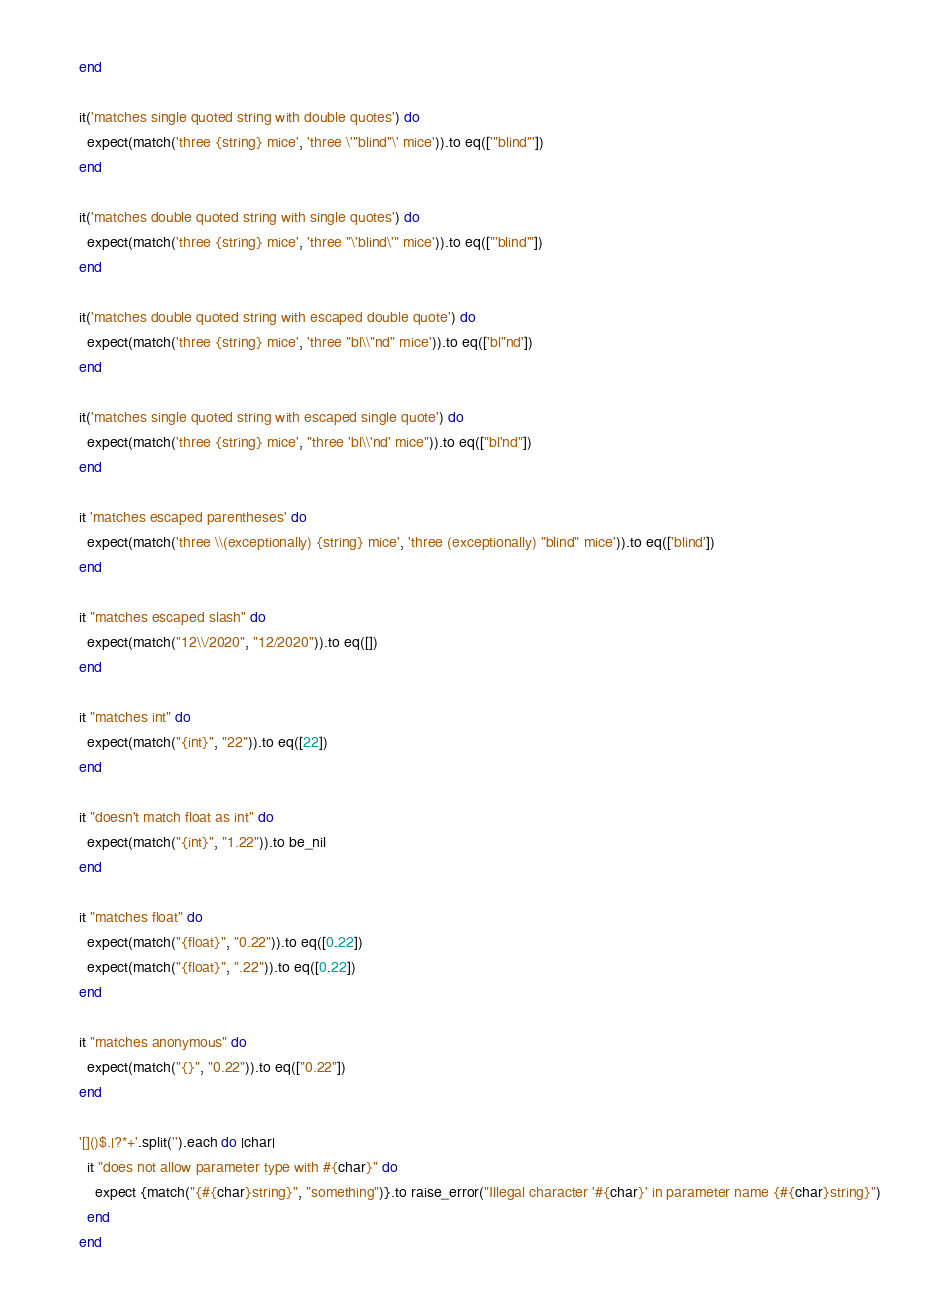Convert code to text. <code><loc_0><loc_0><loc_500><loc_500><_Ruby_>      end

      it('matches single quoted string with double quotes') do
        expect(match('three {string} mice', 'three \'"blind"\' mice')).to eq(['"blind"'])
      end

      it('matches double quoted string with single quotes') do
        expect(match('three {string} mice', 'three "\'blind\'" mice')).to eq(["'blind'"])
      end

      it('matches double quoted string with escaped double quote') do
        expect(match('three {string} mice', 'three "bl\\"nd" mice')).to eq(['bl"nd'])
      end

      it('matches single quoted string with escaped single quote') do
        expect(match('three {string} mice', "three 'bl\\'nd' mice")).to eq(["bl'nd"])
      end

      it 'matches escaped parentheses' do
        expect(match('three \\(exceptionally) {string} mice', 'three (exceptionally) "blind" mice')).to eq(['blind'])
      end

      it "matches escaped slash" do
        expect(match("12\\/2020", "12/2020")).to eq([])
      end

      it "matches int" do
        expect(match("{int}", "22")).to eq([22])
      end

      it "doesn't match float as int" do
        expect(match("{int}", "1.22")).to be_nil
      end

      it "matches float" do
        expect(match("{float}", "0.22")).to eq([0.22])
        expect(match("{float}", ".22")).to eq([0.22])
      end

      it "matches anonymous" do
        expect(match("{}", "0.22")).to eq(["0.22"])
      end

      '[]()$.|?*+'.split('').each do |char|
        it "does not allow parameter type with #{char}" do
          expect {match("{#{char}string}", "something")}.to raise_error("Illegal character '#{char}' in parameter name {#{char}string}")
        end
      end
</code> 